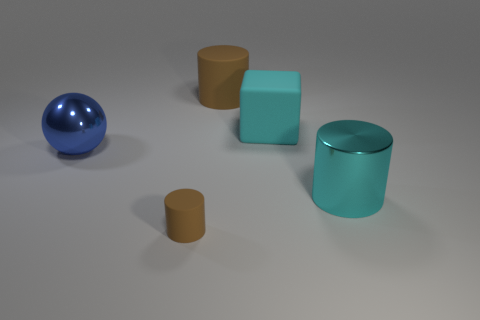Is there any other thing that has the same shape as the blue shiny thing?
Make the answer very short. No. There is a cylinder that is behind the large cylinder that is on the right side of the cyan rubber cube; what is its material?
Your response must be concise. Rubber. There is a rubber block that is the same size as the sphere; what is its color?
Provide a short and direct response. Cyan. Do the small matte object and the brown object to the right of the small cylinder have the same shape?
Your response must be concise. Yes. What is the shape of the large thing that is the same color as the shiny cylinder?
Give a very brief answer. Cube. How many matte cubes are to the right of the brown matte thing on the left side of the brown matte object behind the cyan rubber cube?
Ensure brevity in your answer.  1. There is a brown object that is to the right of the brown cylinder in front of the large blue object; what size is it?
Give a very brief answer. Large. What is the size of the cyan cylinder that is the same material as the blue sphere?
Give a very brief answer. Large. There is a rubber object that is to the left of the big cyan block and on the right side of the small brown object; what shape is it?
Ensure brevity in your answer.  Cylinder. Are there the same number of large objects that are in front of the rubber block and yellow balls?
Ensure brevity in your answer.  No. 